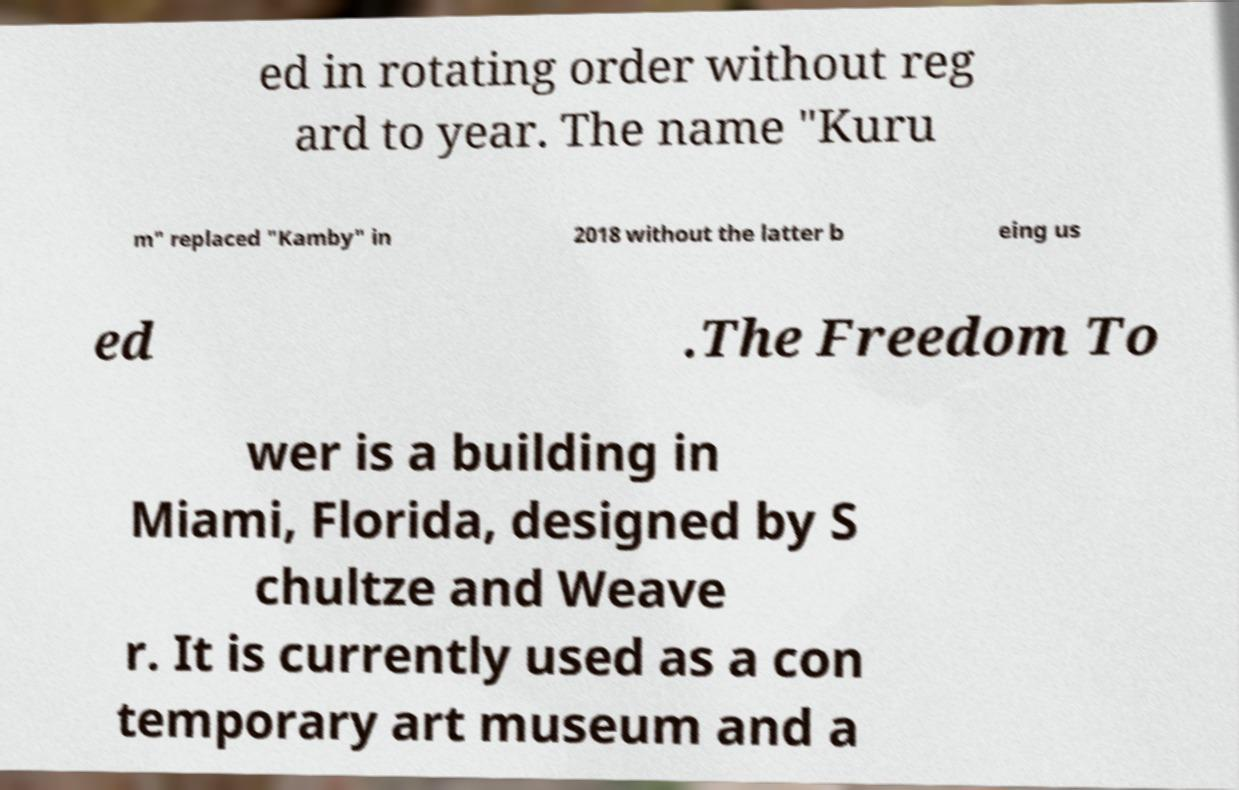Can you read and provide the text displayed in the image?This photo seems to have some interesting text. Can you extract and type it out for me? ed in rotating order without reg ard to year. The name "Kuru m" replaced "Kamby" in 2018 without the latter b eing us ed .The Freedom To wer is a building in Miami, Florida, designed by S chultze and Weave r. It is currently used as a con temporary art museum and a 